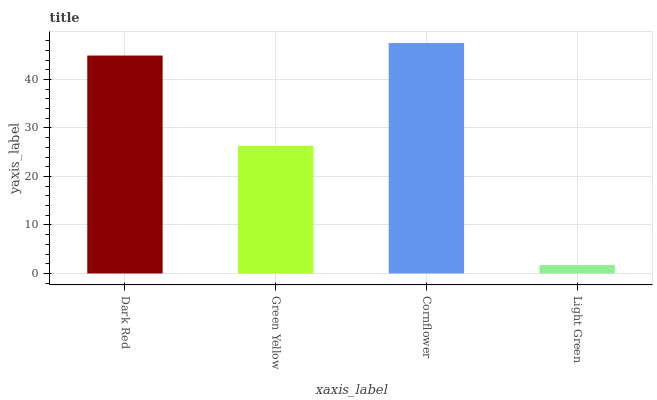Is Green Yellow the minimum?
Answer yes or no. No. Is Green Yellow the maximum?
Answer yes or no. No. Is Dark Red greater than Green Yellow?
Answer yes or no. Yes. Is Green Yellow less than Dark Red?
Answer yes or no. Yes. Is Green Yellow greater than Dark Red?
Answer yes or no. No. Is Dark Red less than Green Yellow?
Answer yes or no. No. Is Dark Red the high median?
Answer yes or no. Yes. Is Green Yellow the low median?
Answer yes or no. Yes. Is Cornflower the high median?
Answer yes or no. No. Is Cornflower the low median?
Answer yes or no. No. 